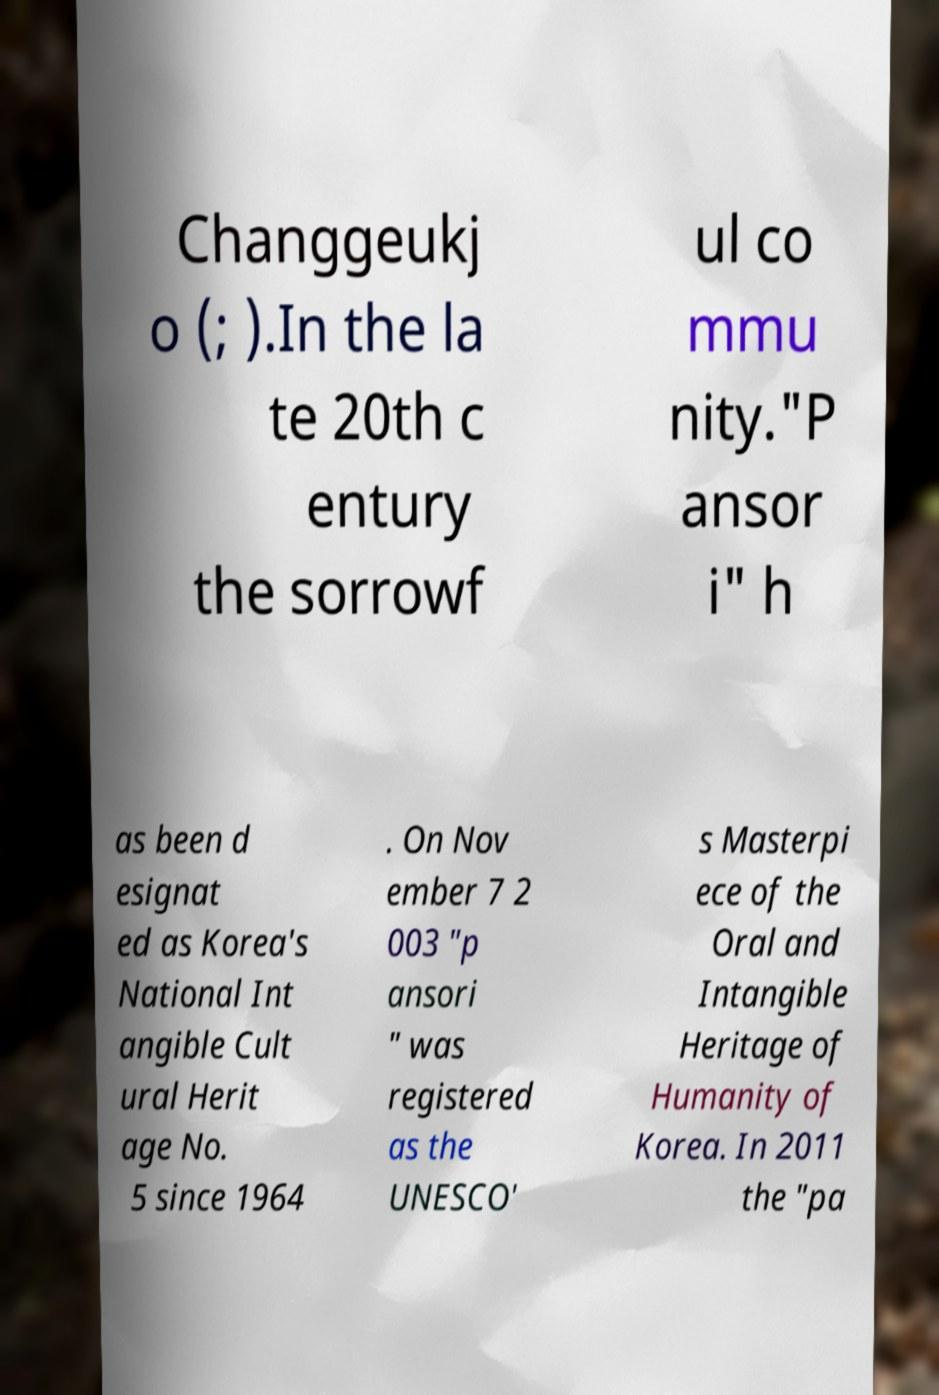Please read and relay the text visible in this image. What does it say? Changgeukj o (; ).In the la te 20th c entury the sorrowf ul co mmu nity."P ansor i" h as been d esignat ed as Korea's National Int angible Cult ural Herit age No. 5 since 1964 . On Nov ember 7 2 003 "p ansori " was registered as the UNESCO' s Masterpi ece of the Oral and Intangible Heritage of Humanity of Korea. In 2011 the "pa 